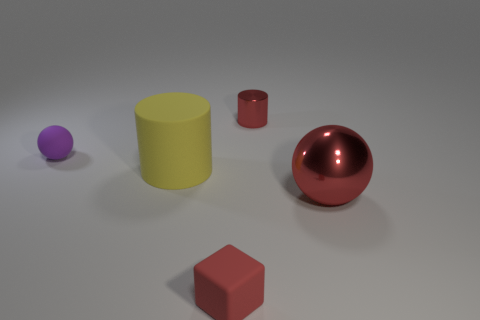Is the shape of the yellow thing the same as the shiny thing that is to the left of the metal sphere?
Your answer should be compact. Yes. Are there fewer large red metal objects behind the large yellow matte thing than cylinders that are on the left side of the tiny red metallic object?
Keep it short and to the point. Yes. There is a purple thing that is the same shape as the big red metal thing; what material is it?
Ensure brevity in your answer.  Rubber. Do the rubber cylinder and the rubber ball have the same color?
Offer a very short reply. No. The purple thing that is the same material as the block is what shape?
Your answer should be very brief. Sphere. How many other big red objects are the same shape as the big shiny thing?
Give a very brief answer. 0. What is the shape of the red object that is in front of the big thing that is right of the small shiny object?
Your answer should be very brief. Cube. Is the size of the cylinder that is behind the matte sphere the same as the purple object?
Your answer should be compact. Yes. How big is the object that is behind the big yellow object and on the left side of the small block?
Keep it short and to the point. Small. What number of other objects have the same size as the yellow matte thing?
Your response must be concise. 1. 